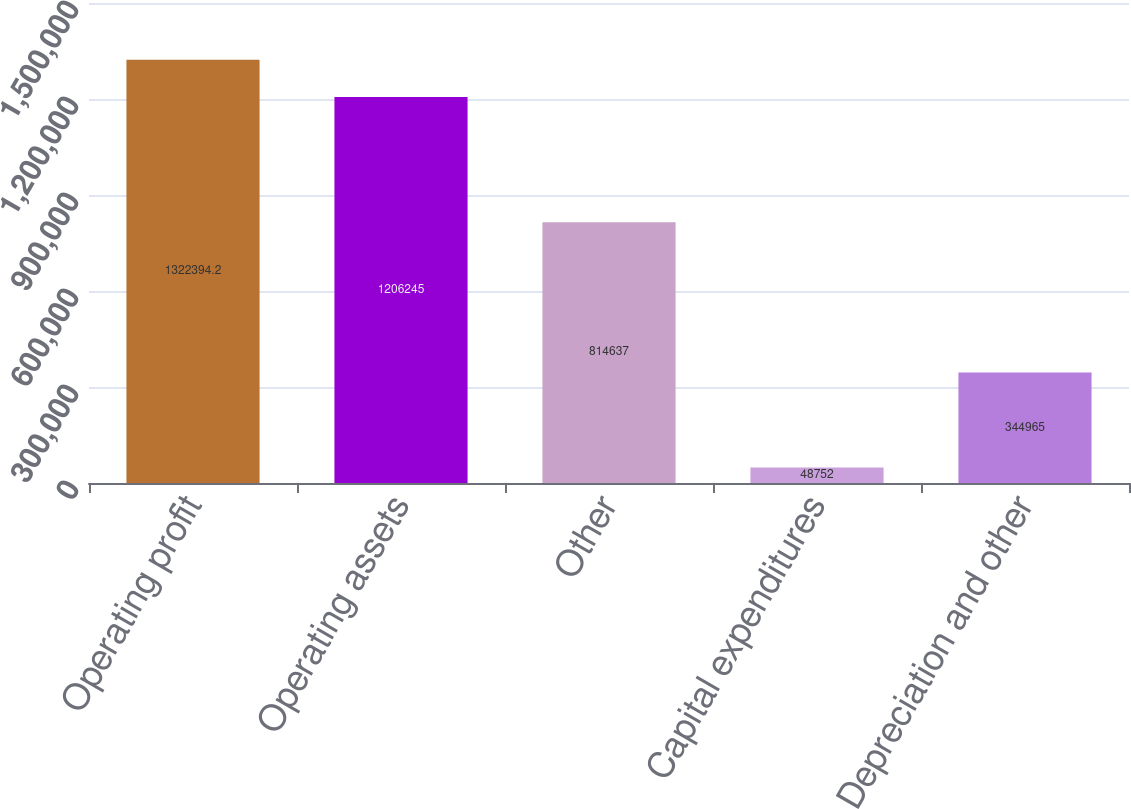Convert chart. <chart><loc_0><loc_0><loc_500><loc_500><bar_chart><fcel>Operating profit<fcel>Operating assets<fcel>Other<fcel>Capital expenditures<fcel>Depreciation and other<nl><fcel>1.32239e+06<fcel>1.20624e+06<fcel>814637<fcel>48752<fcel>344965<nl></chart> 